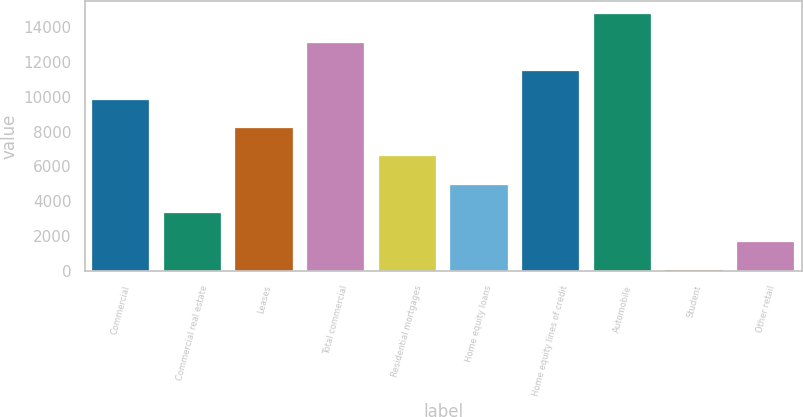Convert chart to OTSL. <chart><loc_0><loc_0><loc_500><loc_500><bar_chart><fcel>Commercial<fcel>Commercial real estate<fcel>Leases<fcel>Total commercial<fcel>Residential mortgages<fcel>Home equity loans<fcel>Home equity lines of credit<fcel>Automobile<fcel>Student<fcel>Other retail<nl><fcel>9829.8<fcel>3322.6<fcel>8203<fcel>13083.4<fcel>6576.2<fcel>4949.4<fcel>11456.6<fcel>14710.2<fcel>69<fcel>1695.8<nl></chart> 